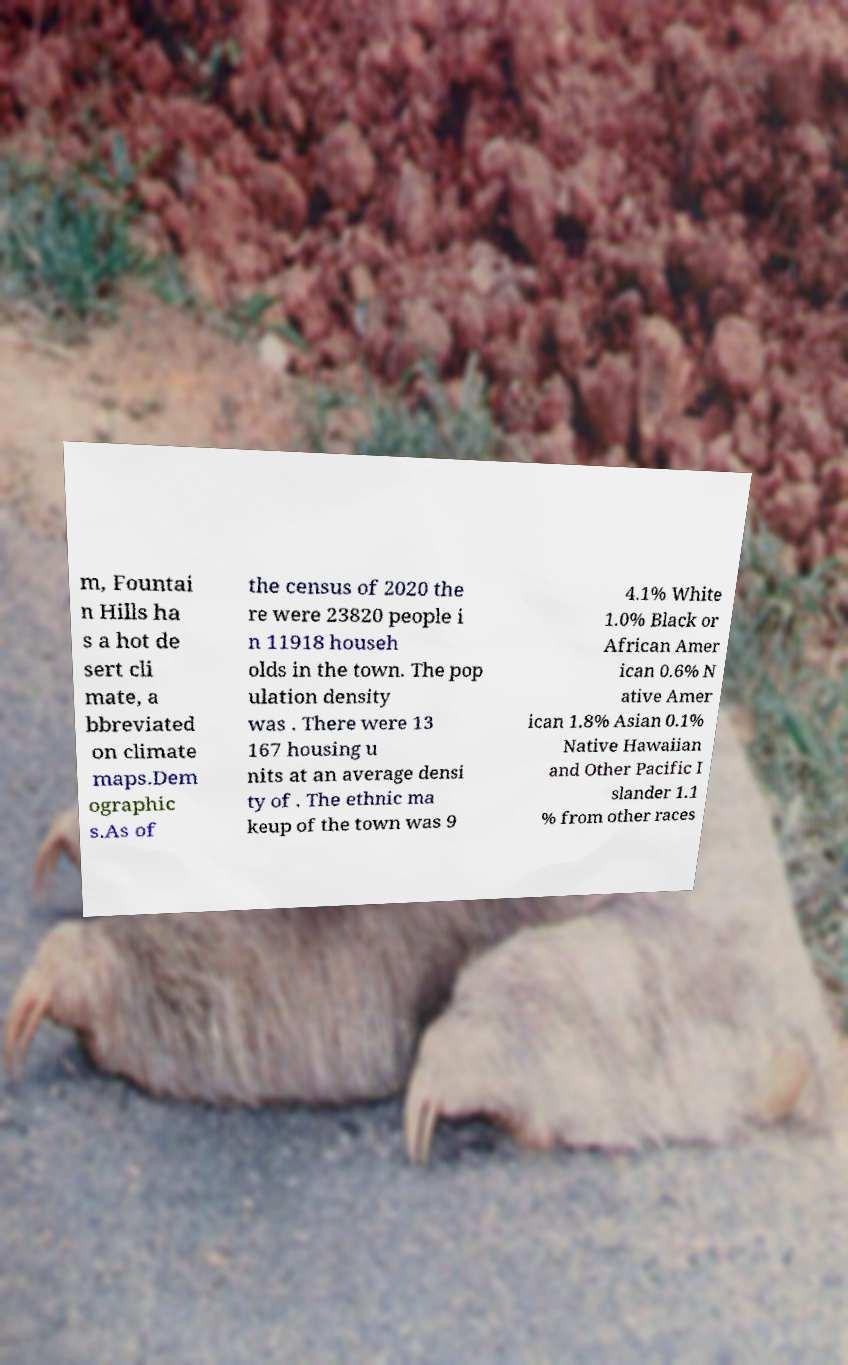I need the written content from this picture converted into text. Can you do that? m, Fountai n Hills ha s a hot de sert cli mate, a bbreviated on climate maps.Dem ographic s.As of the census of 2020 the re were 23820 people i n 11918 househ olds in the town. The pop ulation density was . There were 13 167 housing u nits at an average densi ty of . The ethnic ma keup of the town was 9 4.1% White 1.0% Black or African Amer ican 0.6% N ative Amer ican 1.8% Asian 0.1% Native Hawaiian and Other Pacific I slander 1.1 % from other races 